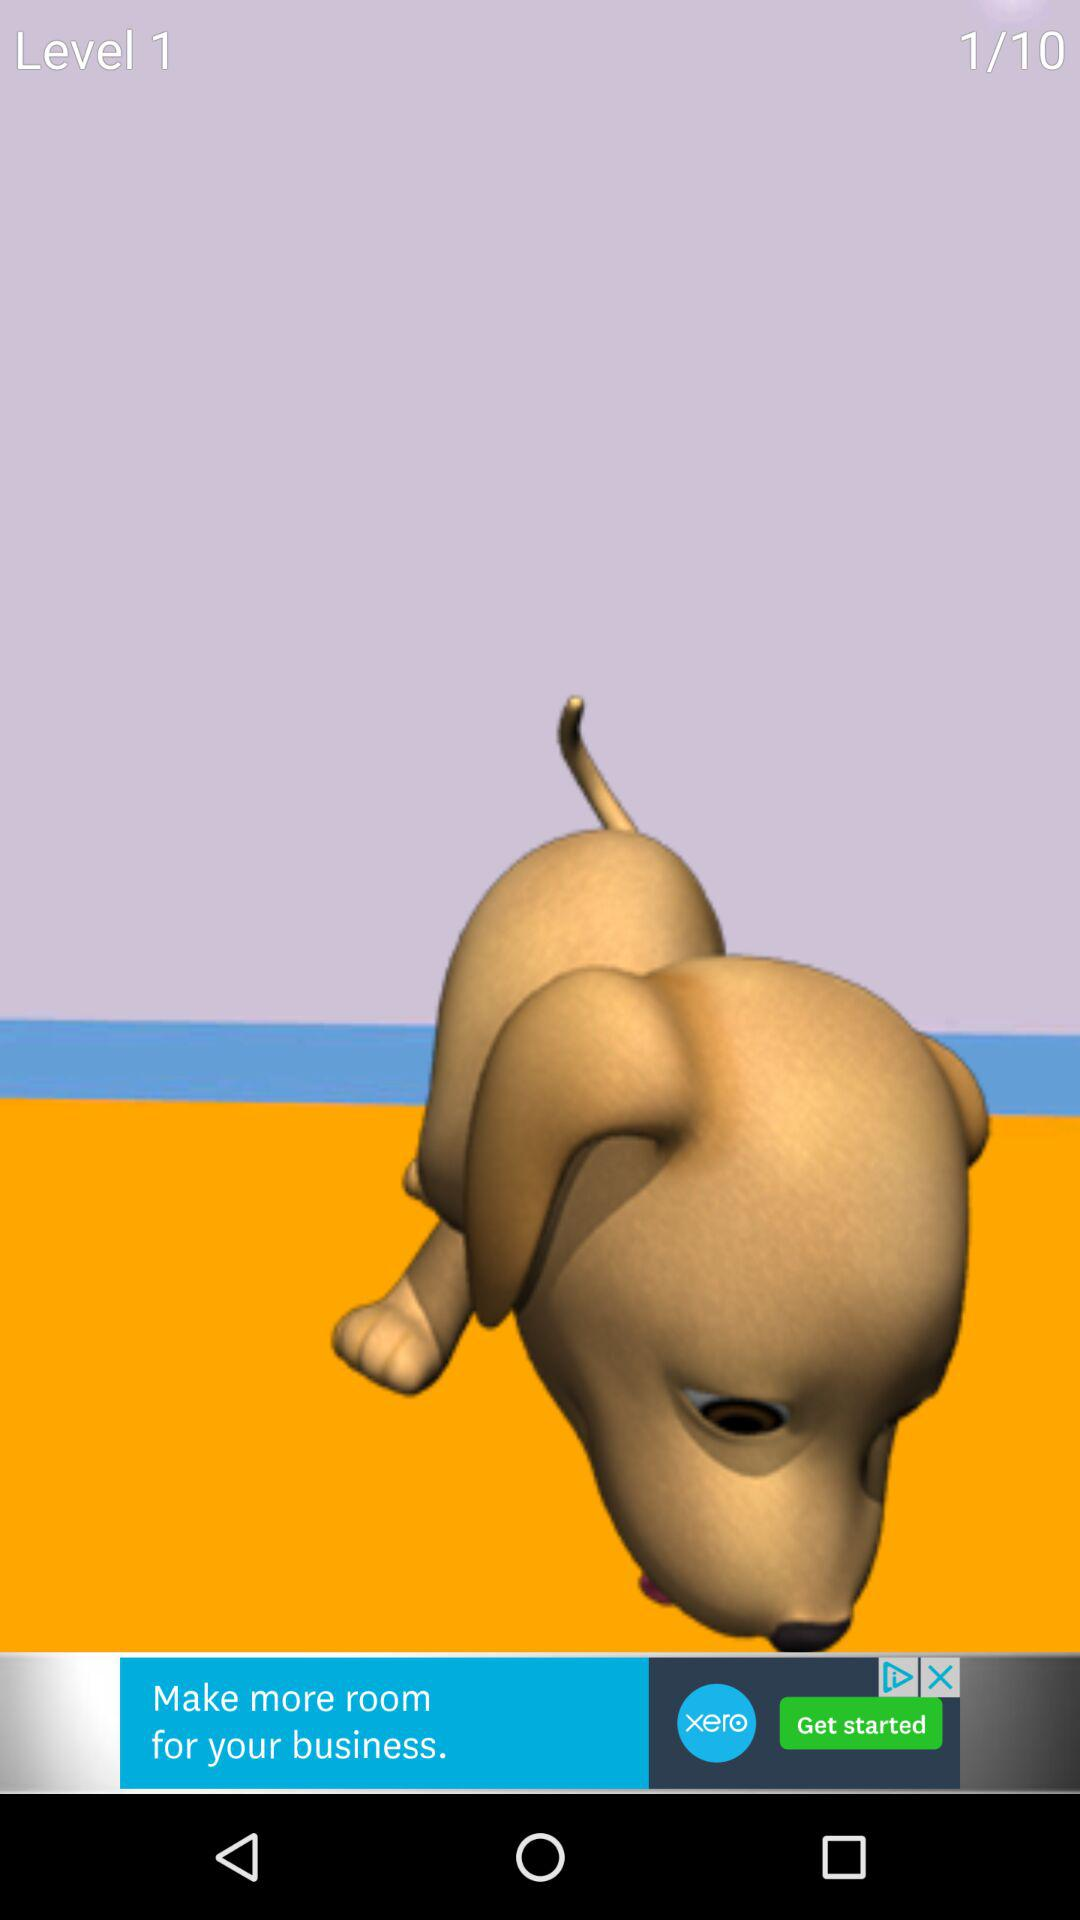How many more levels are there than the current level?
Answer the question using a single word or phrase. 9 